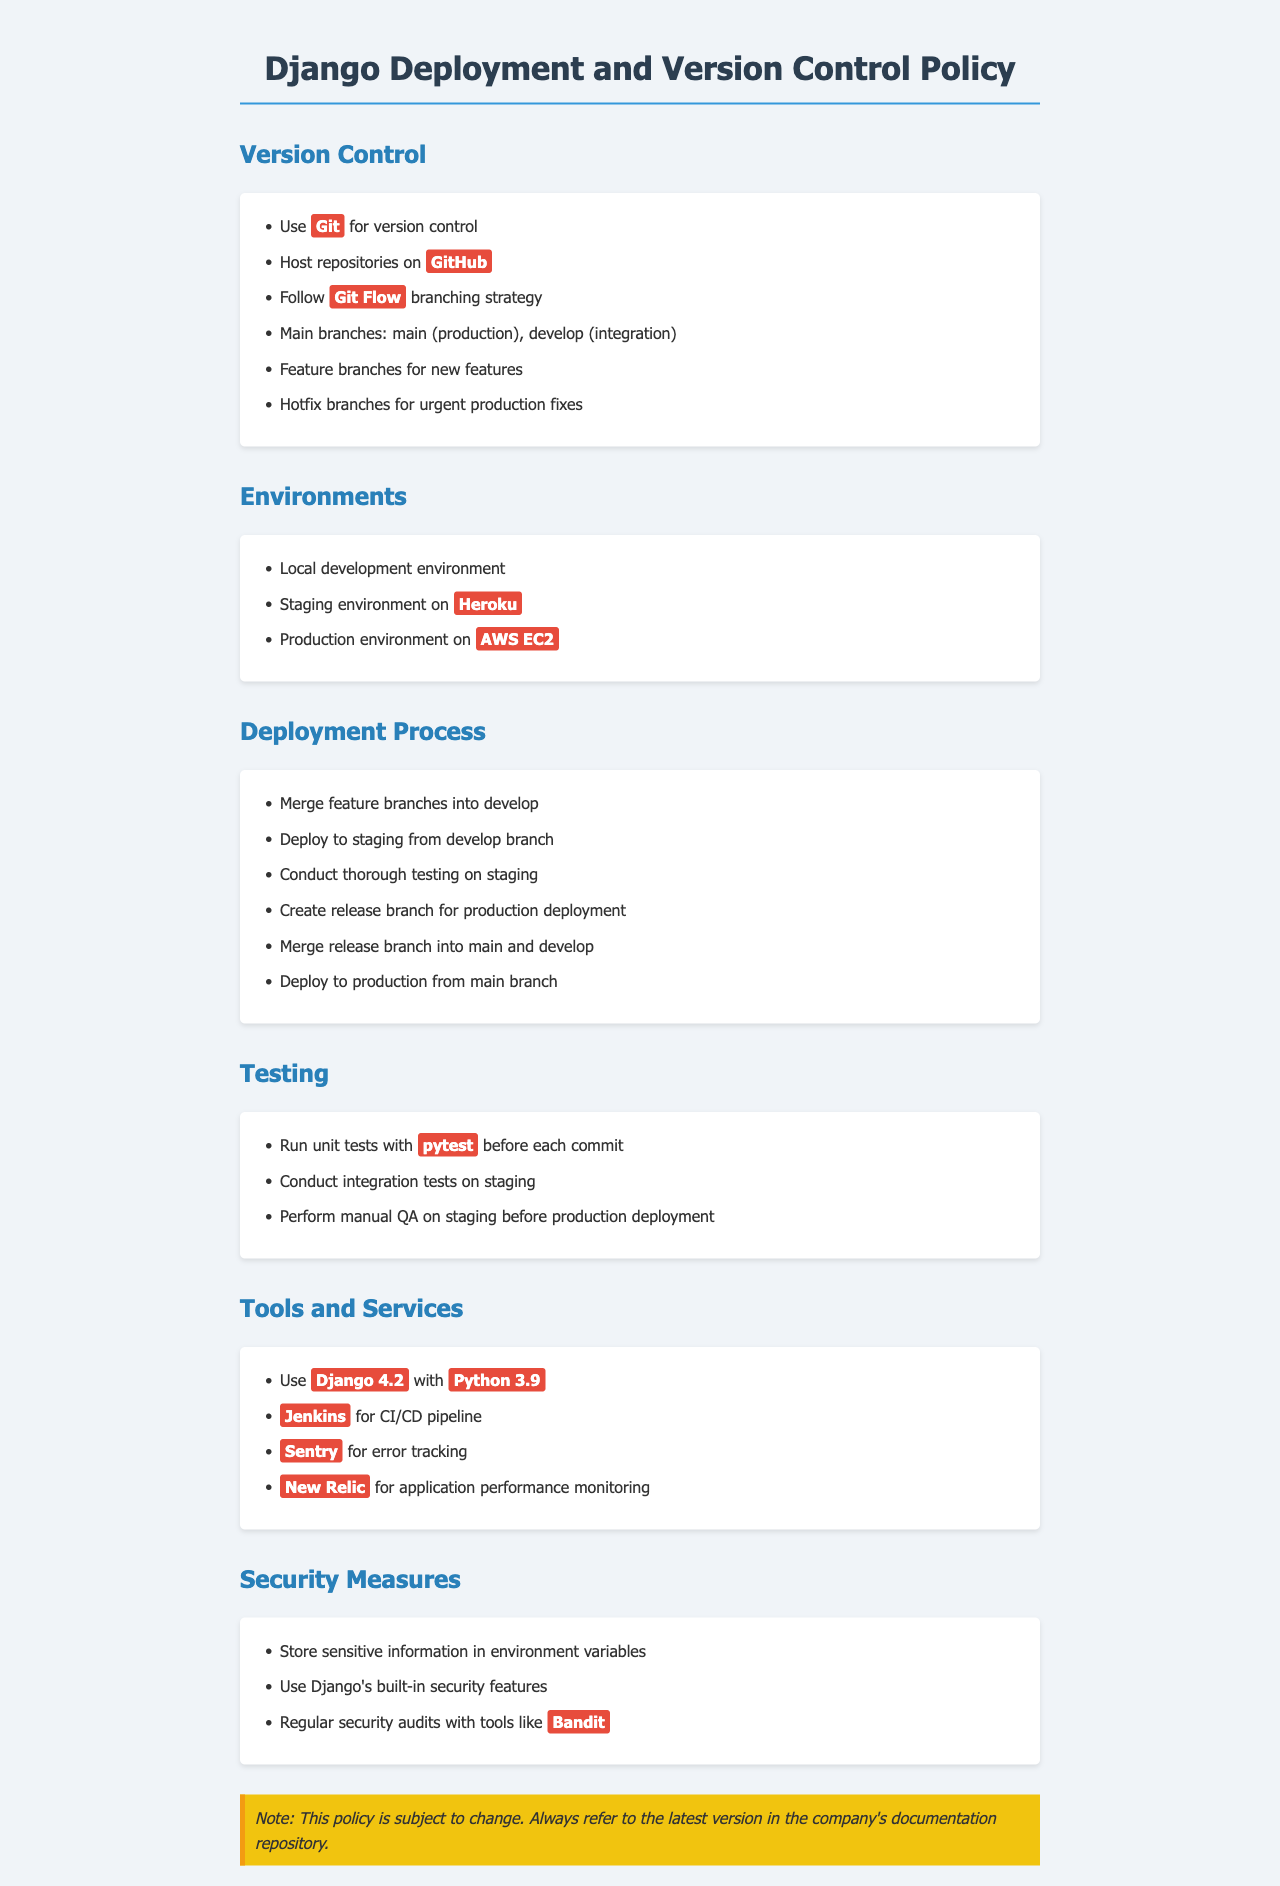What version control system is recommended? The document specifies that Git is used for version control.
Answer: Git What is the hosting platform for repositories? The document states that repositories should be hosted on GitHub.
Answer: GitHub What is the main branch for production? The document indicates that the main branch for production is called main.
Answer: main Where is the staging environment hosted? The document mentions that the staging environment is hosted on Heroku.
Answer: Heroku Which tool is used for error tracking? The document lists Sentry as the tool for error tracking.
Answer: Sentry What type of tests are run before each commit? It specifies that unit tests are run with pytest before each commit.
Answer: pytest What must be done before deploying to production? The document states that manual QA is performed on staging before production deployment.
Answer: manual QA Which version of Django is used? According to the document, Django 4.2 is the version used.
Answer: Django 4.2 What is the strategy followed for branching? The document mentions following the Git Flow branching strategy.
Answer: Git Flow 